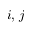Convert formula to latex. <formula><loc_0><loc_0><loc_500><loc_500>i , \, j</formula> 